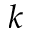Convert formula to latex. <formula><loc_0><loc_0><loc_500><loc_500>k</formula> 